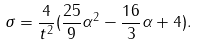<formula> <loc_0><loc_0><loc_500><loc_500>\sigma = \frac { 4 } { t ^ { 2 } } ( \frac { 2 5 } { 9 } \alpha ^ { 2 } - \frac { 1 6 } { 3 } \alpha + 4 ) .</formula> 